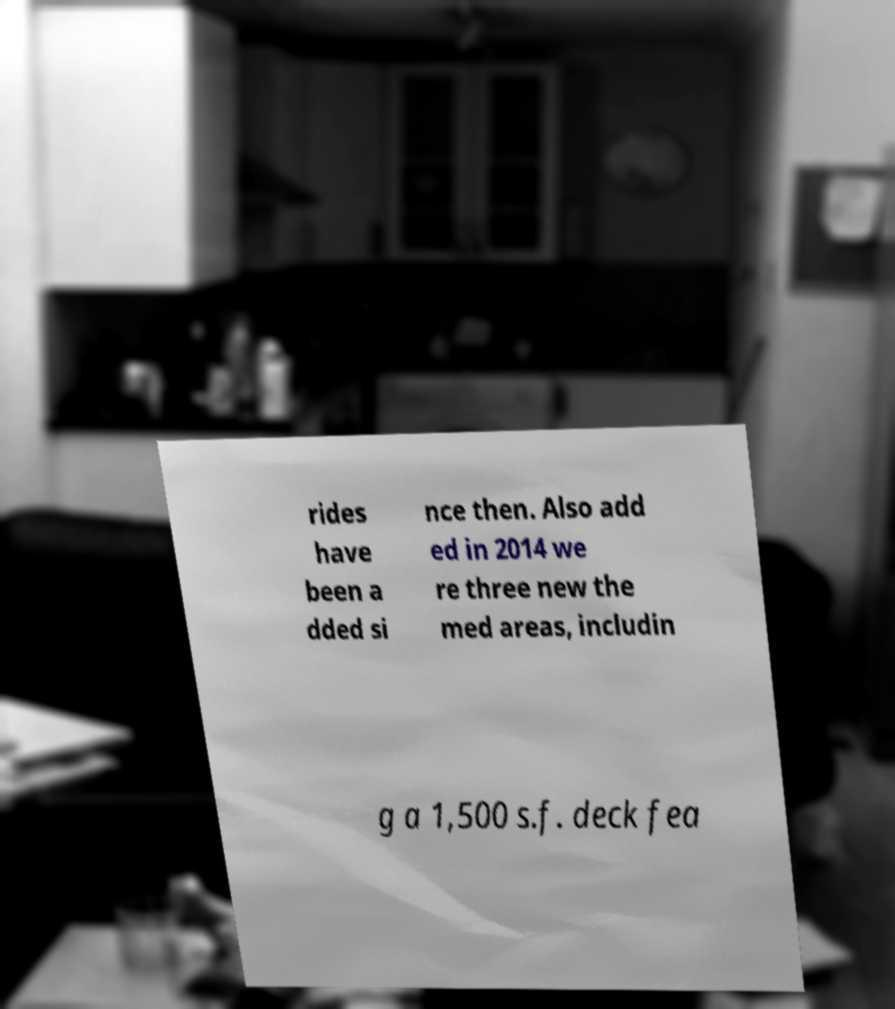What messages or text are displayed in this image? I need them in a readable, typed format. rides have been a dded si nce then. Also add ed in 2014 we re three new the med areas, includin g a 1,500 s.f. deck fea 